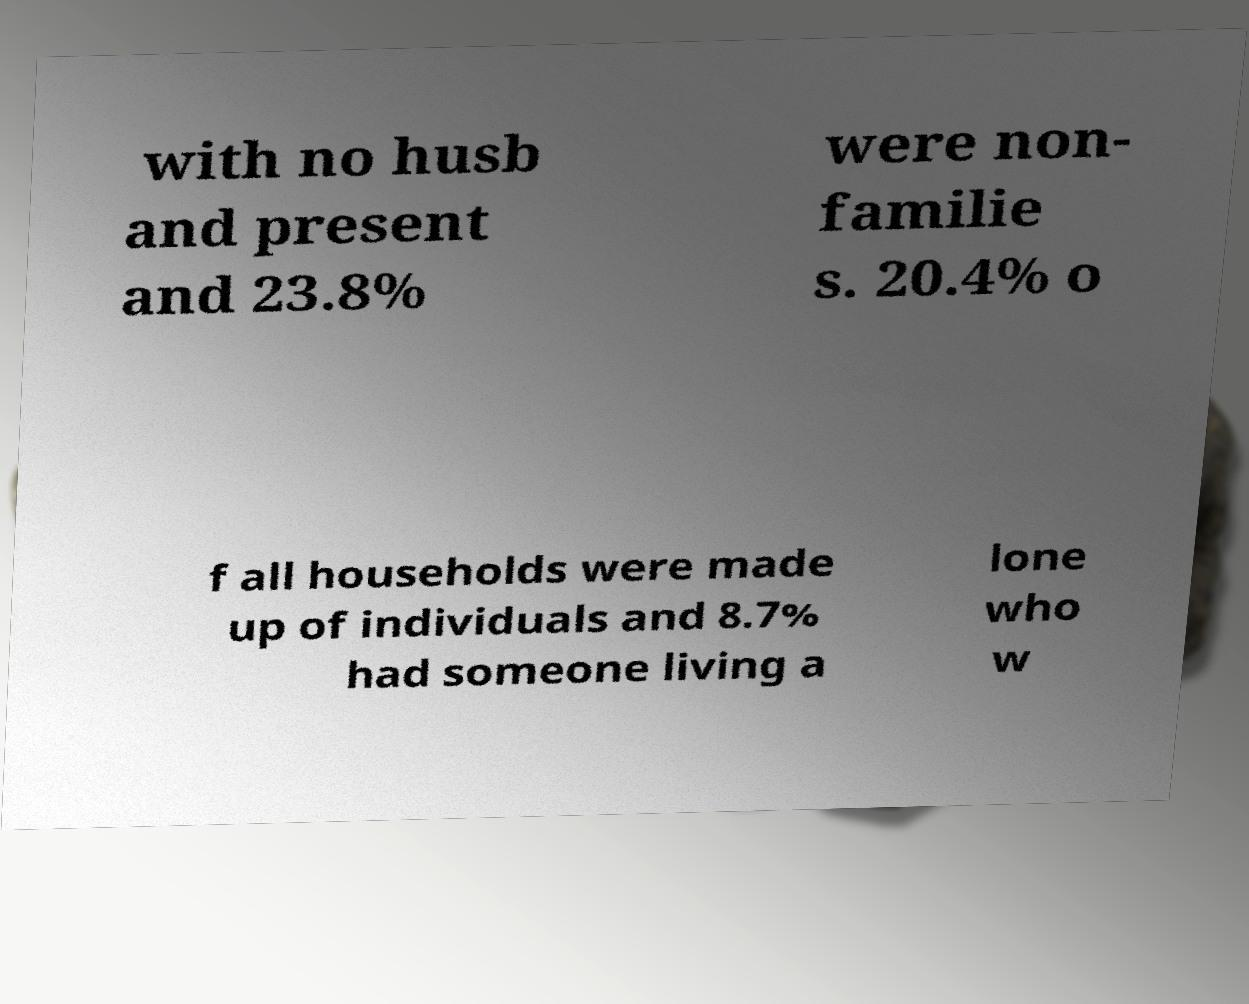Could you extract and type out the text from this image? with no husb and present and 23.8% were non- familie s. 20.4% o f all households were made up of individuals and 8.7% had someone living a lone who w 